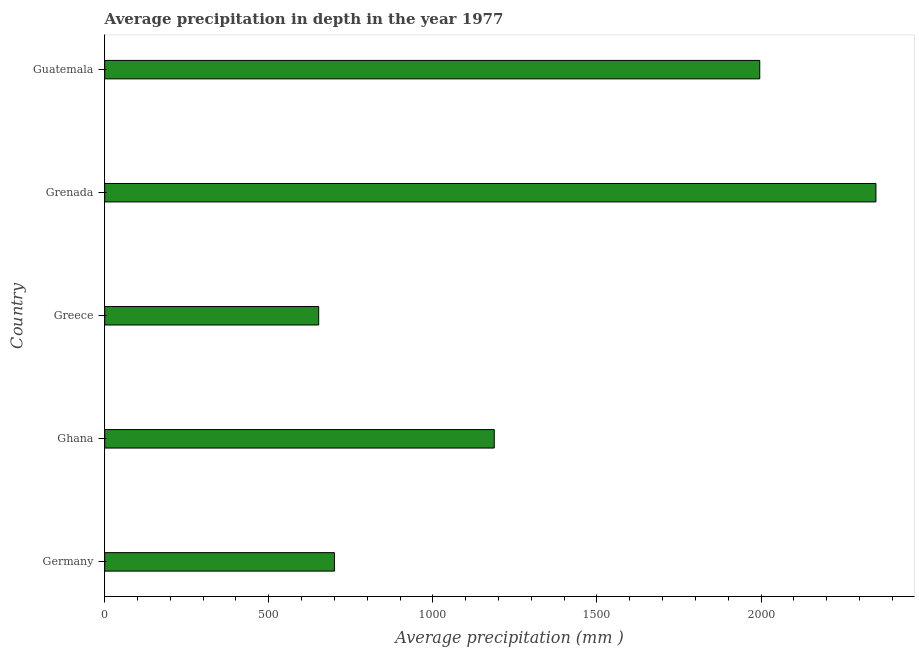Does the graph contain grids?
Your response must be concise. No. What is the title of the graph?
Give a very brief answer. Average precipitation in depth in the year 1977. What is the label or title of the X-axis?
Provide a succinct answer. Average precipitation (mm ). What is the average precipitation in depth in Grenada?
Keep it short and to the point. 2350. Across all countries, what is the maximum average precipitation in depth?
Give a very brief answer. 2350. Across all countries, what is the minimum average precipitation in depth?
Ensure brevity in your answer.  652. In which country was the average precipitation in depth maximum?
Offer a terse response. Grenada. What is the sum of the average precipitation in depth?
Make the answer very short. 6885. What is the difference between the average precipitation in depth in Germany and Greece?
Your answer should be very brief. 48. What is the average average precipitation in depth per country?
Offer a very short reply. 1377. What is the median average precipitation in depth?
Your answer should be compact. 1187. What is the ratio of the average precipitation in depth in Ghana to that in Guatemala?
Your response must be concise. 0.59. What is the difference between the highest and the second highest average precipitation in depth?
Your answer should be very brief. 354. Is the sum of the average precipitation in depth in Germany and Greece greater than the maximum average precipitation in depth across all countries?
Provide a short and direct response. No. What is the difference between the highest and the lowest average precipitation in depth?
Your answer should be compact. 1698. In how many countries, is the average precipitation in depth greater than the average average precipitation in depth taken over all countries?
Provide a short and direct response. 2. How many bars are there?
Ensure brevity in your answer.  5. Are all the bars in the graph horizontal?
Provide a short and direct response. Yes. How many countries are there in the graph?
Your response must be concise. 5. Are the values on the major ticks of X-axis written in scientific E-notation?
Keep it short and to the point. No. What is the Average precipitation (mm ) in Germany?
Your answer should be compact. 700. What is the Average precipitation (mm ) in Ghana?
Offer a very short reply. 1187. What is the Average precipitation (mm ) in Greece?
Provide a succinct answer. 652. What is the Average precipitation (mm ) in Grenada?
Offer a terse response. 2350. What is the Average precipitation (mm ) in Guatemala?
Keep it short and to the point. 1996. What is the difference between the Average precipitation (mm ) in Germany and Ghana?
Your response must be concise. -487. What is the difference between the Average precipitation (mm ) in Germany and Greece?
Provide a short and direct response. 48. What is the difference between the Average precipitation (mm ) in Germany and Grenada?
Provide a succinct answer. -1650. What is the difference between the Average precipitation (mm ) in Germany and Guatemala?
Your response must be concise. -1296. What is the difference between the Average precipitation (mm ) in Ghana and Greece?
Ensure brevity in your answer.  535. What is the difference between the Average precipitation (mm ) in Ghana and Grenada?
Your answer should be compact. -1163. What is the difference between the Average precipitation (mm ) in Ghana and Guatemala?
Your answer should be compact. -809. What is the difference between the Average precipitation (mm ) in Greece and Grenada?
Keep it short and to the point. -1698. What is the difference between the Average precipitation (mm ) in Greece and Guatemala?
Provide a short and direct response. -1344. What is the difference between the Average precipitation (mm ) in Grenada and Guatemala?
Provide a succinct answer. 354. What is the ratio of the Average precipitation (mm ) in Germany to that in Ghana?
Give a very brief answer. 0.59. What is the ratio of the Average precipitation (mm ) in Germany to that in Greece?
Keep it short and to the point. 1.07. What is the ratio of the Average precipitation (mm ) in Germany to that in Grenada?
Ensure brevity in your answer.  0.3. What is the ratio of the Average precipitation (mm ) in Germany to that in Guatemala?
Provide a short and direct response. 0.35. What is the ratio of the Average precipitation (mm ) in Ghana to that in Greece?
Make the answer very short. 1.82. What is the ratio of the Average precipitation (mm ) in Ghana to that in Grenada?
Your answer should be very brief. 0.51. What is the ratio of the Average precipitation (mm ) in Ghana to that in Guatemala?
Provide a short and direct response. 0.59. What is the ratio of the Average precipitation (mm ) in Greece to that in Grenada?
Your response must be concise. 0.28. What is the ratio of the Average precipitation (mm ) in Greece to that in Guatemala?
Your response must be concise. 0.33. What is the ratio of the Average precipitation (mm ) in Grenada to that in Guatemala?
Your response must be concise. 1.18. 